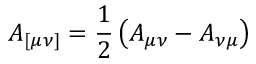<formula> <loc_0><loc_0><loc_500><loc_500>A _ { [ \mu \nu ] } = \frac { 1 } { 2 } \left ( A _ { \mu \nu } - A _ { \nu \mu } \right )</formula> 